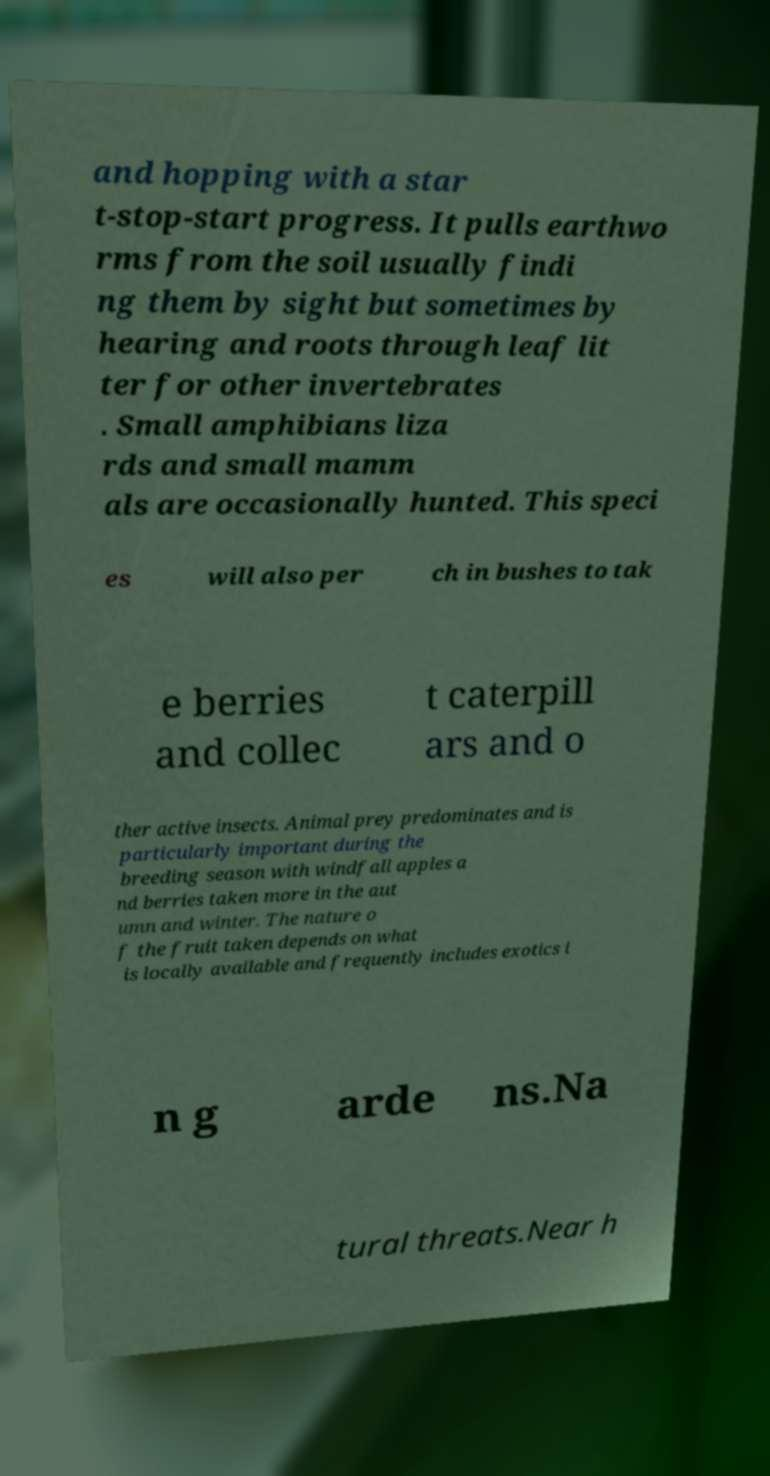Can you read and provide the text displayed in the image?This photo seems to have some interesting text. Can you extract and type it out for me? and hopping with a star t-stop-start progress. It pulls earthwo rms from the soil usually findi ng them by sight but sometimes by hearing and roots through leaf lit ter for other invertebrates . Small amphibians liza rds and small mamm als are occasionally hunted. This speci es will also per ch in bushes to tak e berries and collec t caterpill ars and o ther active insects. Animal prey predominates and is particularly important during the breeding season with windfall apples a nd berries taken more in the aut umn and winter. The nature o f the fruit taken depends on what is locally available and frequently includes exotics i n g arde ns.Na tural threats.Near h 